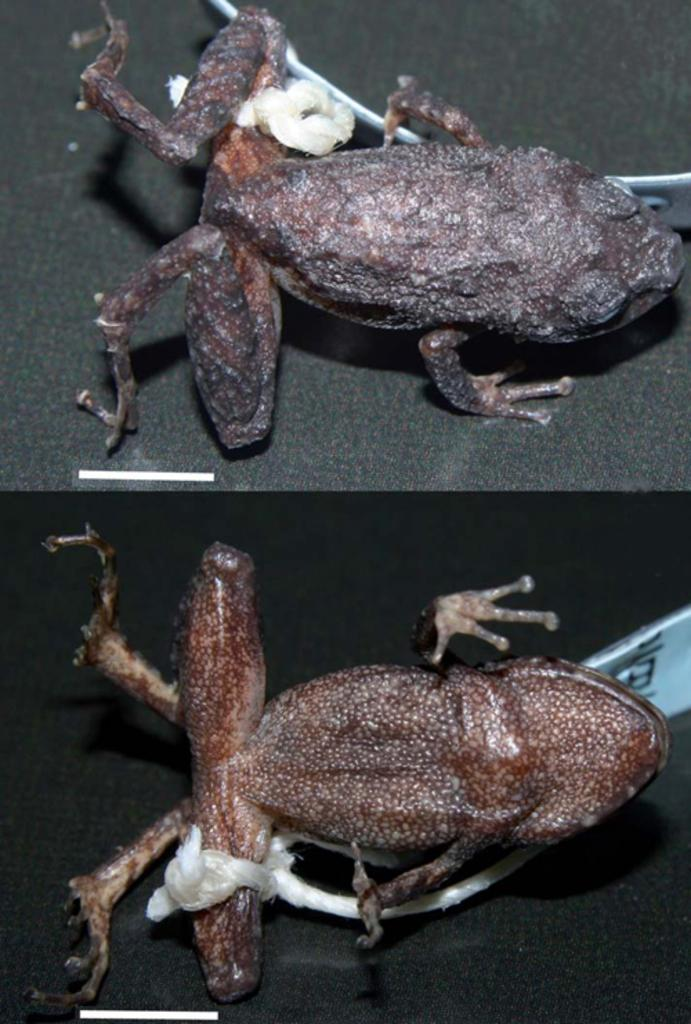What type of animals are featured in the collage in the image? The image contains a collage of frogs. Can you describe the composition of the collage? The collage consists of various images of frogs arranged together. What type of cry can be heard from the farmer in the image? There is no farmer present in the image, so it is not possible to determine what, if any, cry might be heard. 